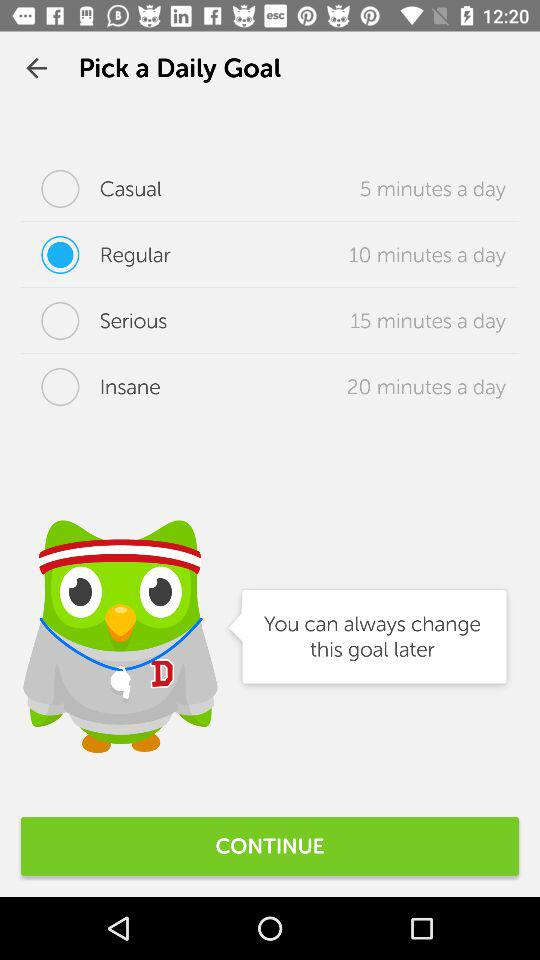How long is the goal "Seriously insane"?
When the provided information is insufficient, respond with <no answer>. <no answer> 